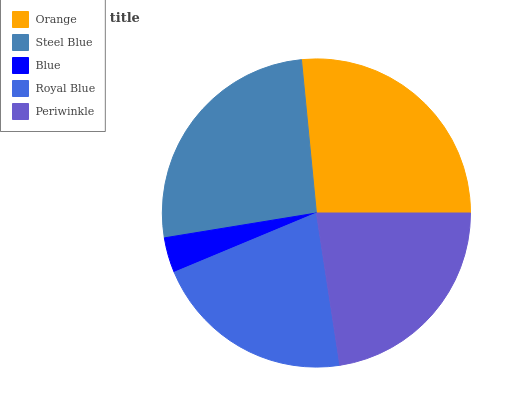Is Blue the minimum?
Answer yes or no. Yes. Is Orange the maximum?
Answer yes or no. Yes. Is Steel Blue the minimum?
Answer yes or no. No. Is Steel Blue the maximum?
Answer yes or no. No. Is Orange greater than Steel Blue?
Answer yes or no. Yes. Is Steel Blue less than Orange?
Answer yes or no. Yes. Is Steel Blue greater than Orange?
Answer yes or no. No. Is Orange less than Steel Blue?
Answer yes or no. No. Is Periwinkle the high median?
Answer yes or no. Yes. Is Periwinkle the low median?
Answer yes or no. Yes. Is Royal Blue the high median?
Answer yes or no. No. Is Royal Blue the low median?
Answer yes or no. No. 